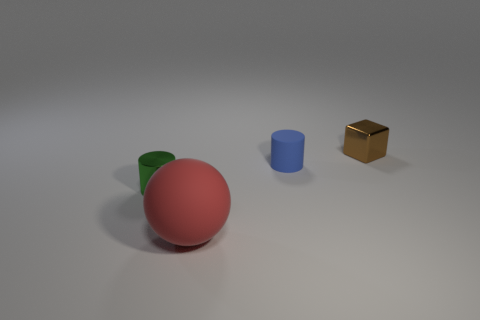Add 2 large green metal objects. How many objects exist? 6 Subtract all spheres. How many objects are left? 3 Add 1 blue cylinders. How many blue cylinders are left? 2 Add 2 large red blocks. How many large red blocks exist? 2 Subtract 1 red balls. How many objects are left? 3 Subtract all big metallic balls. Subtract all small brown metal things. How many objects are left? 3 